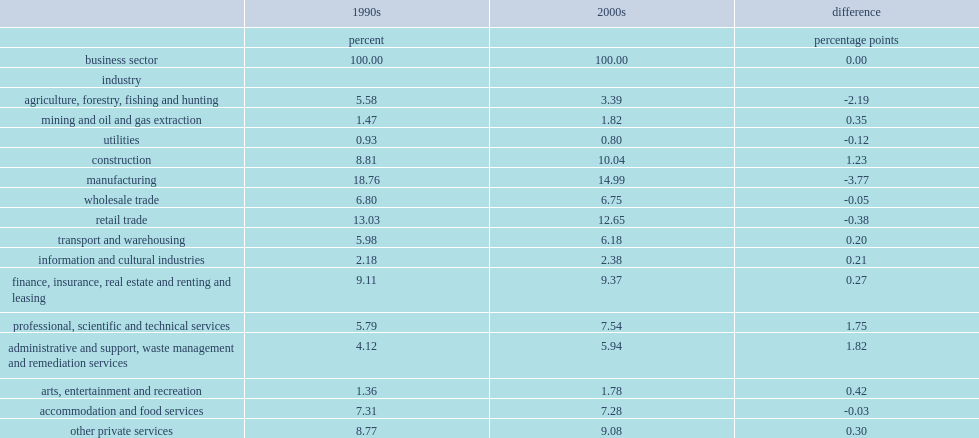Which business sector has experienced the largest absolute change in labour share? Manufacturing. What percent of the mining, oil and gas sector had changed in its labour share? 0.238095. What percent of the mining, oil and gas sector has increased in absolute terms? 1.47 1.82. 